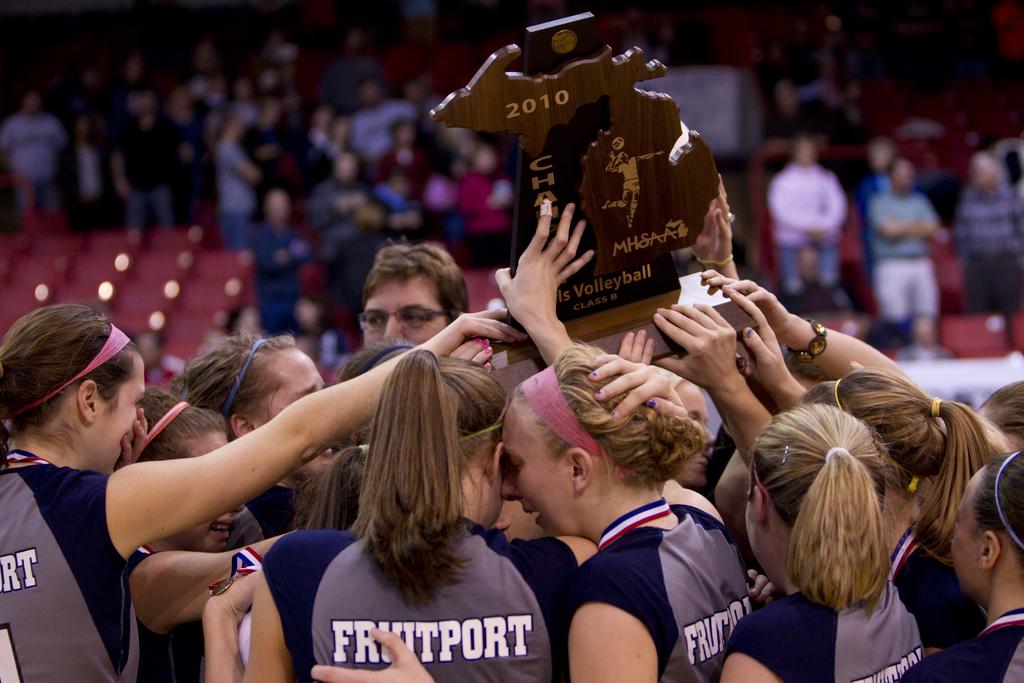What the team play?
Your response must be concise. Volleyball. 